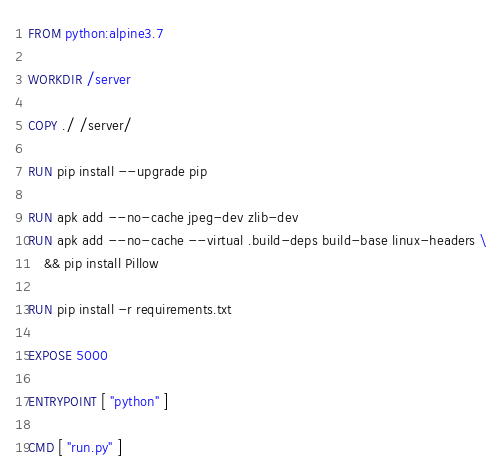<code> <loc_0><loc_0><loc_500><loc_500><_Dockerfile_>FROM python:alpine3.7 

WORKDIR /server

COPY ./ /server/

RUN pip install --upgrade pip

RUN apk add --no-cache jpeg-dev zlib-dev
RUN apk add --no-cache --virtual .build-deps build-base linux-headers \
    && pip install Pillow

RUN pip install -r requirements.txt 

EXPOSE 5000

ENTRYPOINT [ "python" ] 

CMD [ "run.py" ] 




</code> 